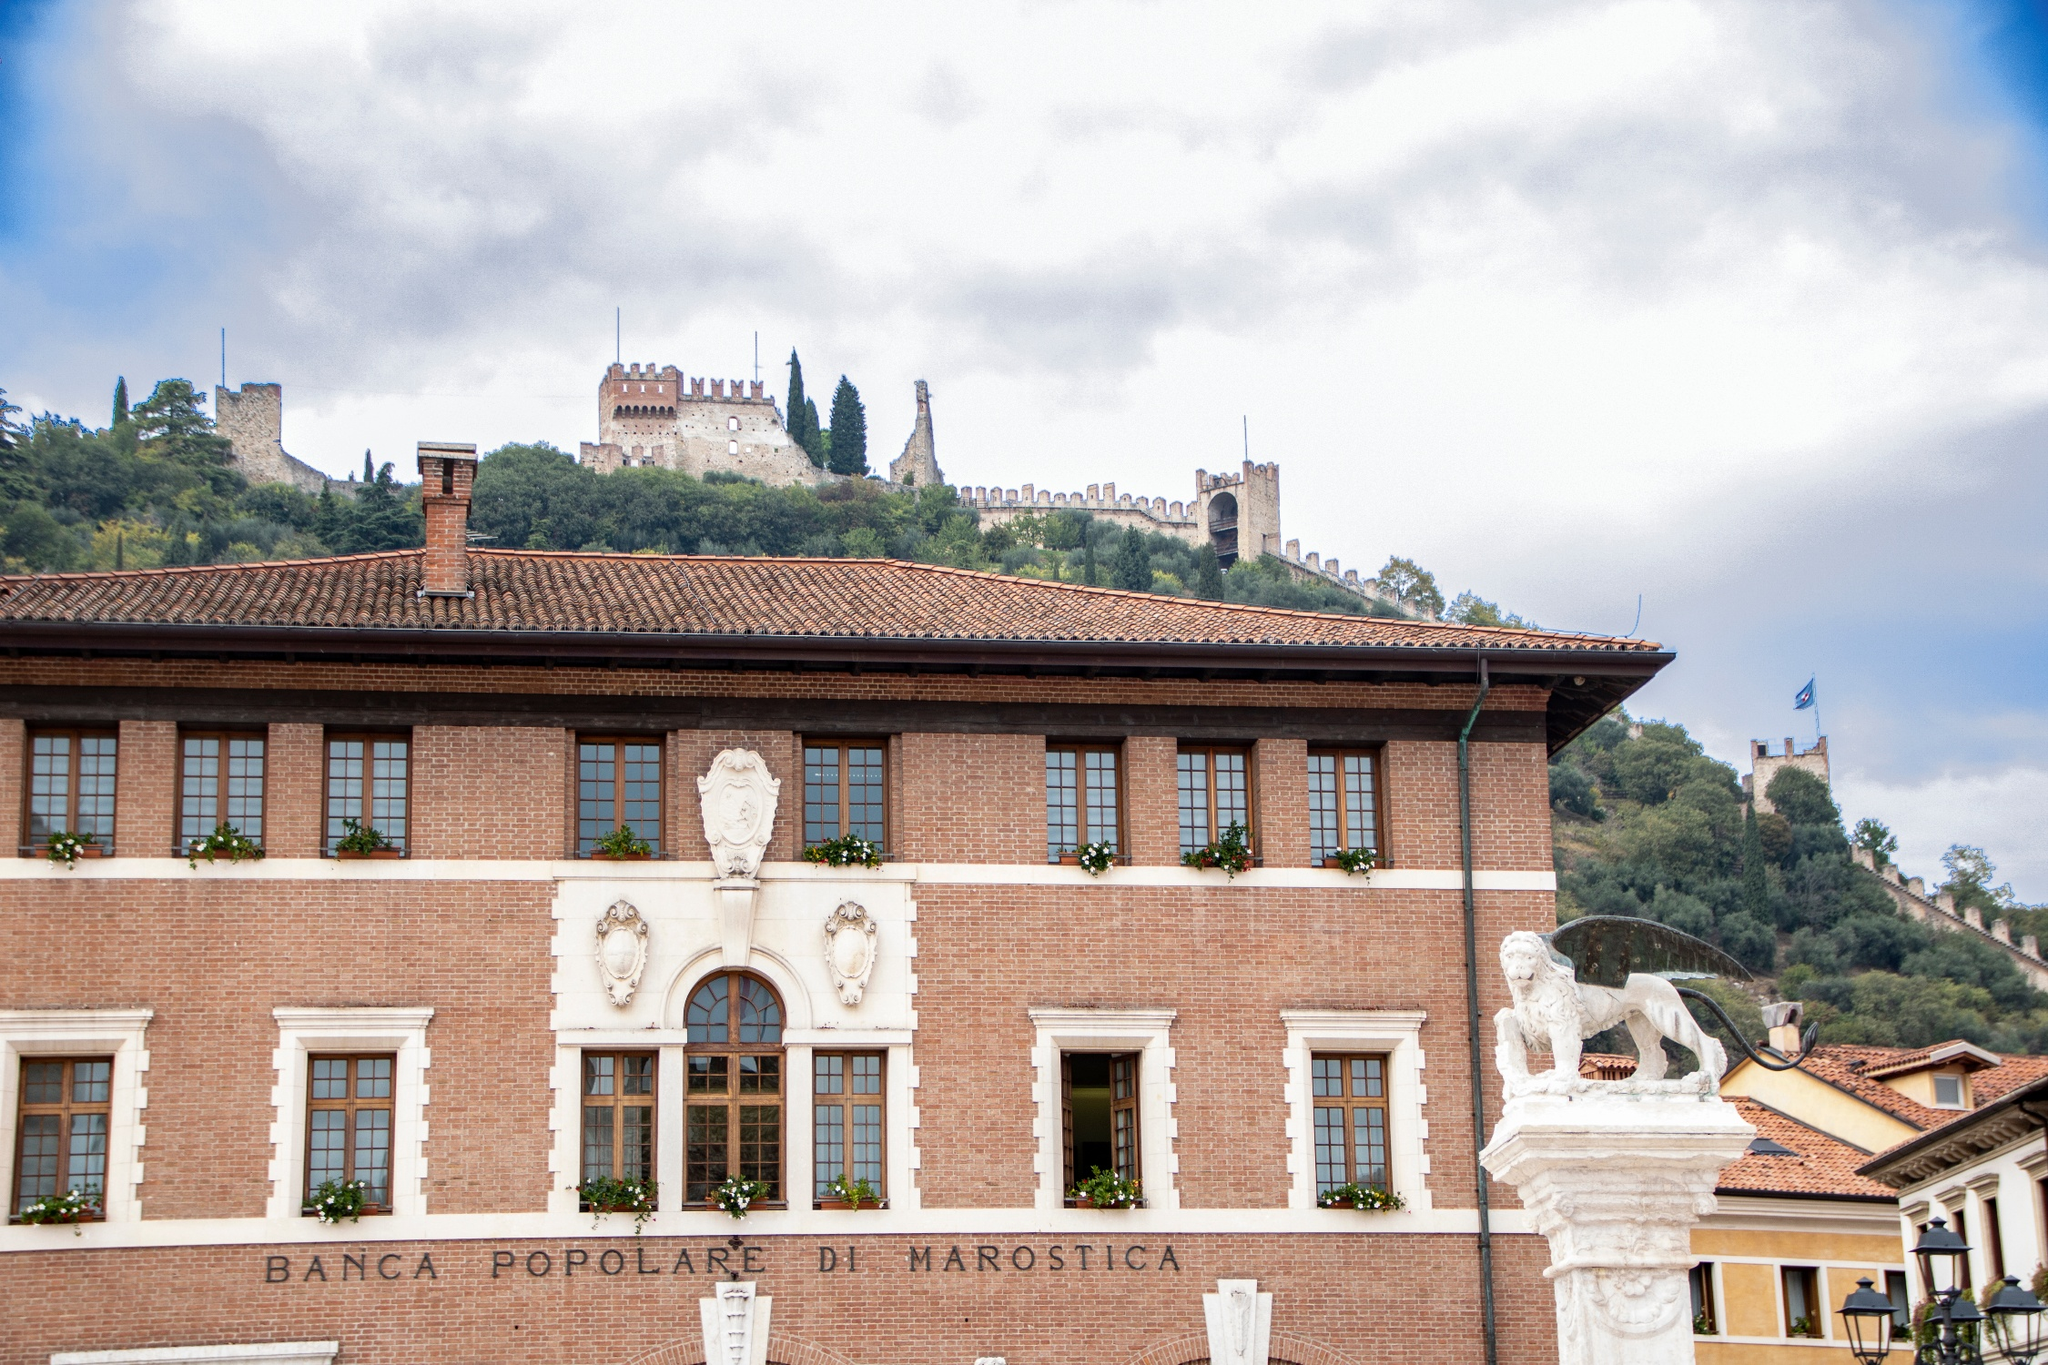Analyze the image in a comprehensive and detailed manner. The image is a rich visual representation of Marostica, Italy, showcasing layers of historical and architectural beauty. The centerpiece is the Banca Popolare di Marostica, a stately two-story brick edifice crowned with a traditional red tile roof, beautifully offset by white window and door trims. The façade is adorned with three prominent arched windows on the second floor, enhancing its architectural elegance. Adding to its grandeur, a stately lion statue stands guard to the building's right, symbolizing strength and majesty.

In the backdrop, the formidable Castello di Marostica majestically sits atop a verdant hill, its stone walls and towers a testament to the town’s Medieval heritage. The castle's imposing presence speaks volumes of Marostica's historical significance. Above this historical tableau, the sky is a picturesque expanse of blue interspersed with fluffy white clouds, casting a serene glow over the scene.

This image encapsulates more than just a picturesque moment; it captures the essence of Marostica's cultural and historical tapestry. Each element in the frame, from the buildings and statues to the castle and sky, weaves together a visual narrative inviting viewers to delve into Marostica's rich heritage and beauty. 